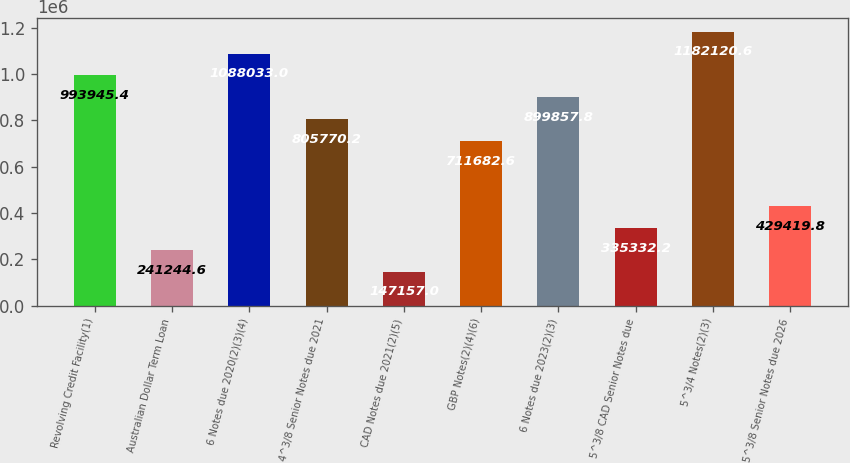Convert chart to OTSL. <chart><loc_0><loc_0><loc_500><loc_500><bar_chart><fcel>Revolving Credit Facility(1)<fcel>Australian Dollar Term Loan<fcel>6 Notes due 2020(2)(3)(4)<fcel>4^3/8 Senior Notes due 2021<fcel>CAD Notes due 2021(2)(5)<fcel>GBP Notes(2)(4)(6)<fcel>6 Notes due 2023(2)(3)<fcel>5^3/8 CAD Senior Notes due<fcel>5^3/4 Notes(2)(3)<fcel>5^3/8 Senior Notes due 2026<nl><fcel>993945<fcel>241245<fcel>1.08803e+06<fcel>805770<fcel>147157<fcel>711683<fcel>899858<fcel>335332<fcel>1.18212e+06<fcel>429420<nl></chart> 